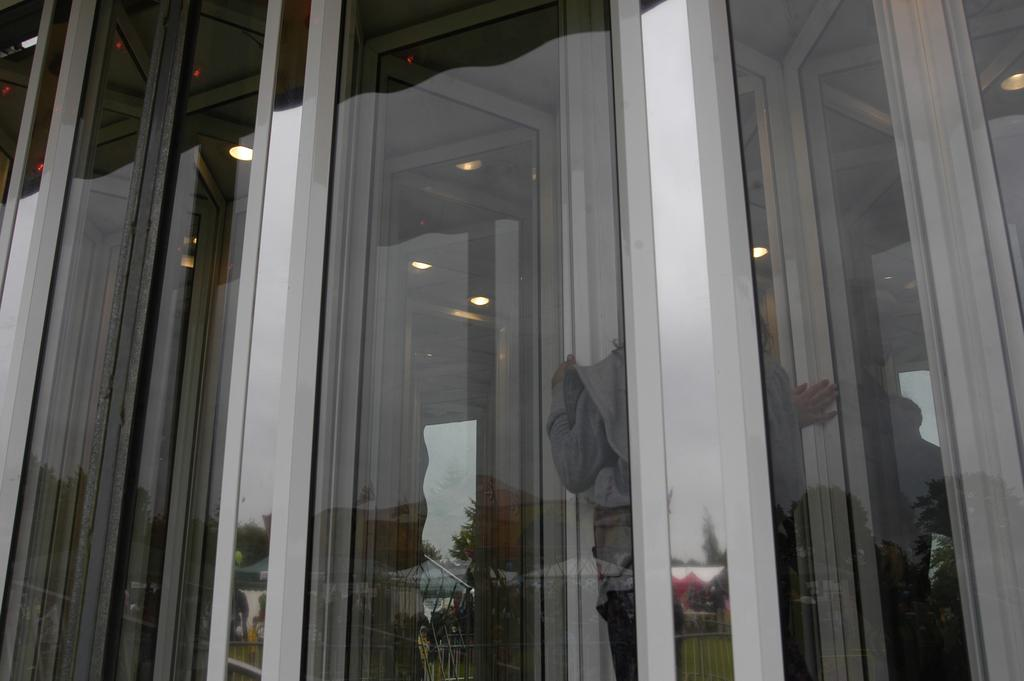What type of wall is present in the image? There is a glass wall in the image. Can you see anyone through the glass wall? Yes, there is a person visible through the glass wall. What is located on the left side of the image? There are lights on the left side of the image. How many ice cubes are on the person's toes in the image? There is no ice or reference to toes in the image, so it is not possible to answer that question. 